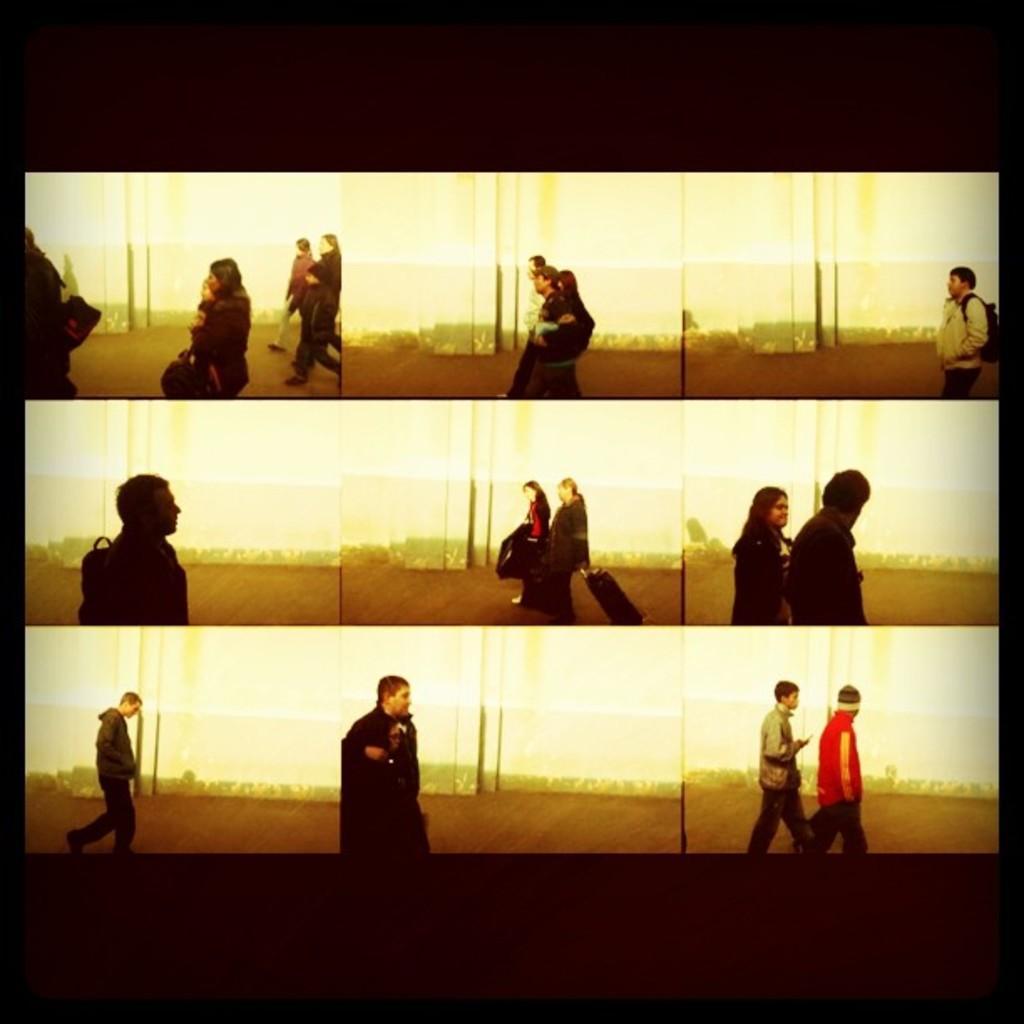How would you summarize this image in a sentence or two? It is a collage picture. In the image few people are walking. 